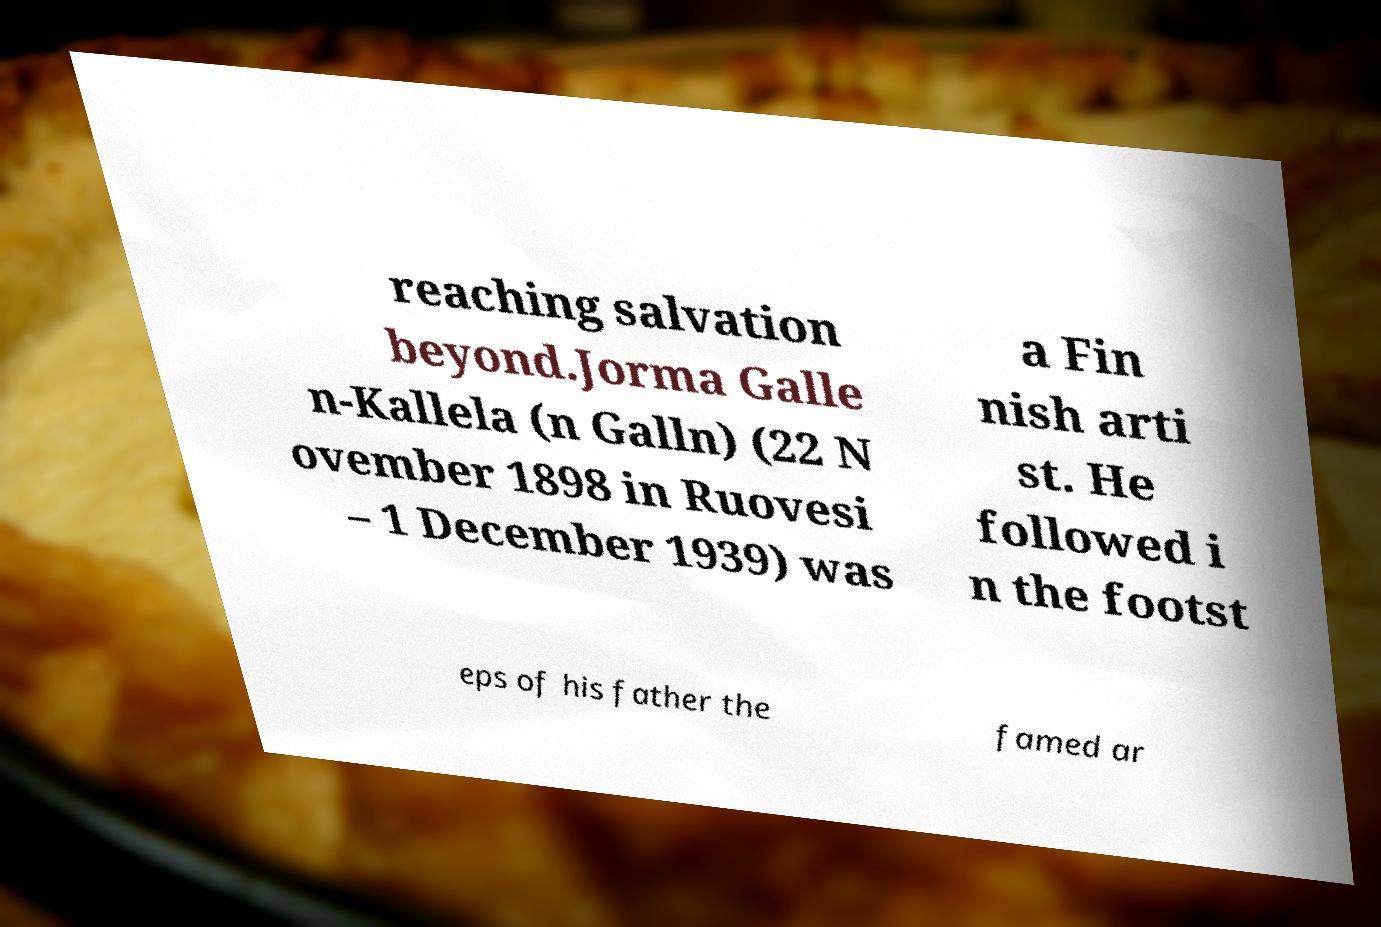Can you read and provide the text displayed in the image?This photo seems to have some interesting text. Can you extract and type it out for me? reaching salvation beyond.Jorma Galle n-Kallela (n Galln) (22 N ovember 1898 in Ruovesi – 1 December 1939) was a Fin nish arti st. He followed i n the footst eps of his father the famed ar 